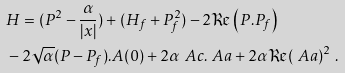<formula> <loc_0><loc_0><loc_500><loc_500>& H = ( P ^ { 2 } - \frac { \alpha } { | x | } ) + ( H _ { f } + P _ { f } ^ { 2 } ) - 2 \Re \left ( P . P _ { f } \right ) \\ & - 2 \sqrt { \alpha } ( P - P _ { f } ) . A ( 0 ) + 2 \alpha \ A c . \ A a + 2 \alpha \Re ( \ A a ) ^ { 2 } \ .</formula> 